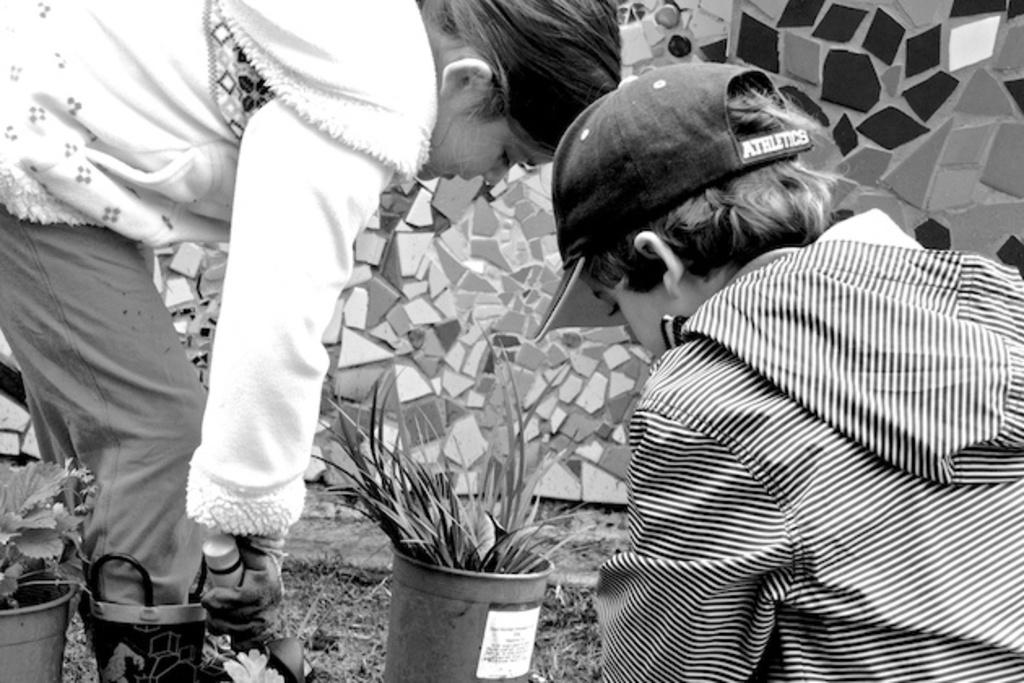How many people are in the image? There are two people in the image. What are the people holding in the image? The people are holding something, but the specific object is not mentioned in the facts. What can be seen in the image besides the people? There are flower pots and a wall in the image. What is the color scheme of the image? The image is in black and white. In which direction are the people combing their hair in the image? There is no mention of hair or a comb in the image, so it is not possible to answer this question. 